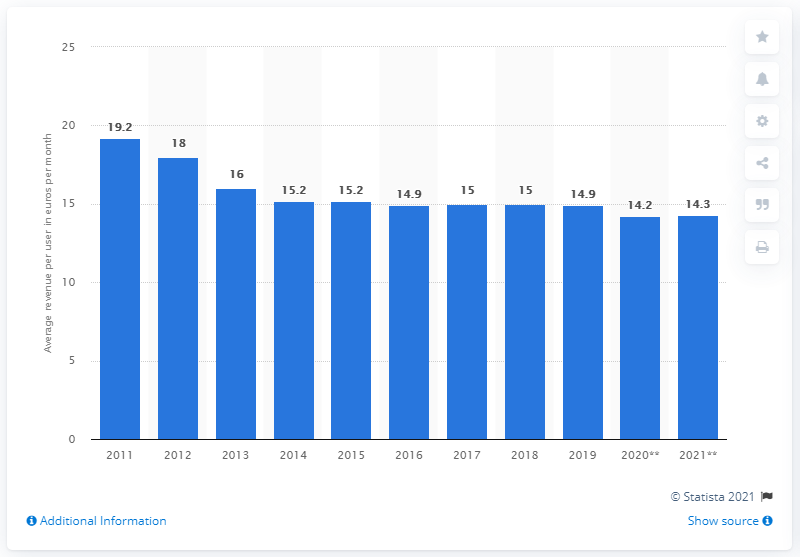Mention a couple of crucial points in this snapshot. The projected revenue per user of mobile broadband customers in Europe is expected to be 14.3 by 2021. 